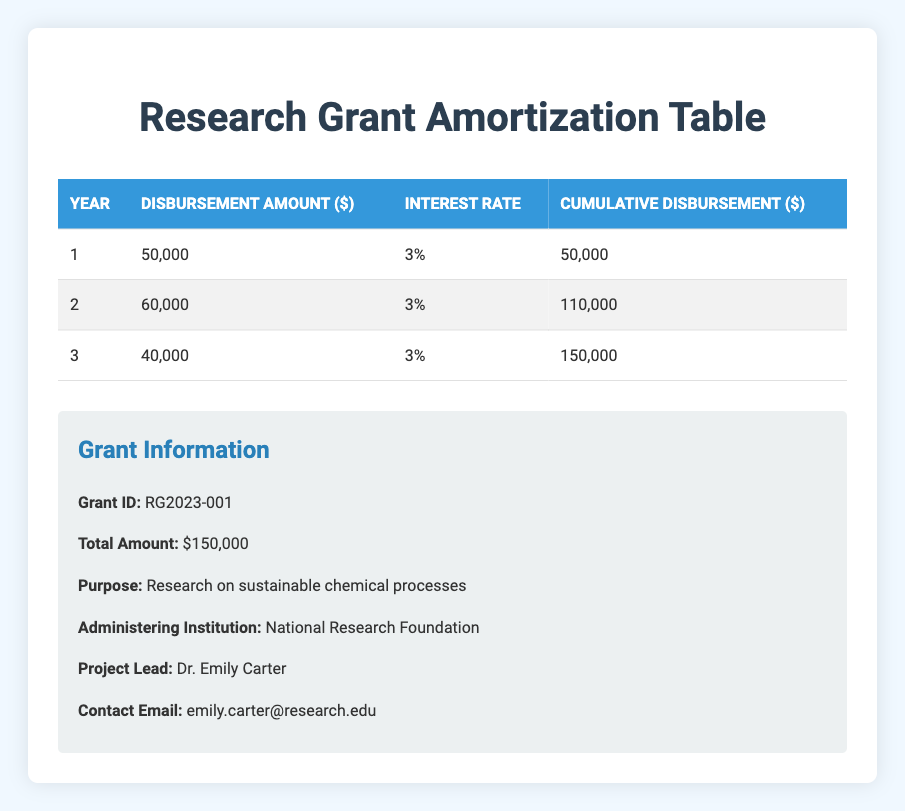What is the total amount of the research grant? The total amount of the research grant is listed in the table under Grant Information as $150,000.
Answer: 150000 How much was disbursed in the second year? From the disbursement schedule, the amount disbursed in the second year is directly mentioned as $60,000.
Answer: 60000 Is the interest rate applied in the table consistent across all years? The interest rate for each year is indicated as 3%, confirming that it is consistent across all the disbursements.
Answer: Yes What is the cumulative disbursement by the end of the third year? Looking at the cumulative disbursement column, by the end of the third year, the cumulative amount is $150,000.
Answer: 150000 What is the difference in disbursement amounts between the first and third years? The disbursement in the first year is $50,000 and in the third year is $40,000. The difference is $50,000 - $40,000 = $10,000.
Answer: 10000 What percentage of the total grant was disbursed in the first year? To find this percentage, take the disbursement amount for the first year ($50,000) and divide it by the total amount of the grant ($150,000), then multiply by 100: (50000 / 150000) * 100 = 33.33%.
Answer: 33.33% What is the total disbursement from years one and two combined? The amounts disbursed in the first and second years are $50,000 and $60,000, respectively. Adding these together gives $50,000 + $60,000 = $110,000.
Answer: 110000 Was the total amount disbursed after two years less than $120,000? Cumulative disbursement after two years is $110,000, which is less than $120,000, confirming the statement is true.
Answer: Yes What would be the average annual disbursement amount over the three years? The total amount disbursed is $150,000 over three years. Dividing this by 3 gives an average of $50,000 per year.
Answer: 50000 